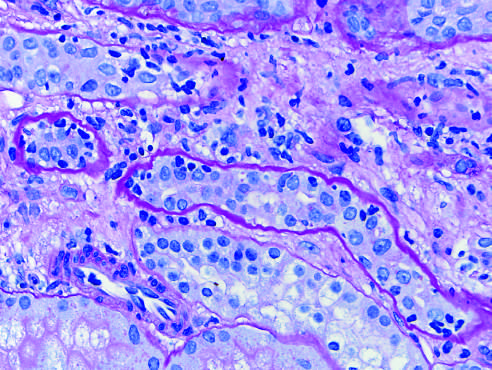what are collapsed tubules outlined by?
Answer the question using a single word or phrase. Wavy basement membranes 